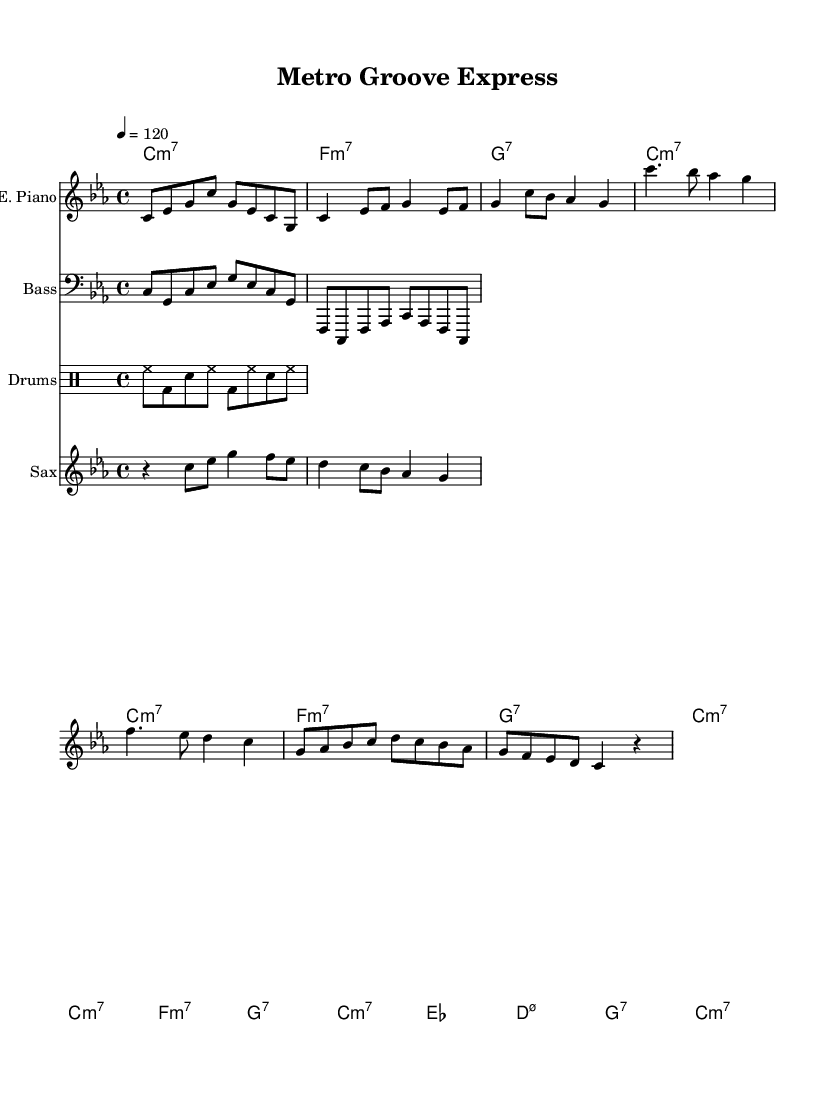What is the key signature of this music? The key signature indicated in the sheet music is C minor, which corresponds to the presence of three flats. This can be inferred from the initial marking in the global section of the code stating \key c \minor.
Answer: C minor What is the time signature of this music? The time signature is found in the global section of the score, specified as \time 4/4. This means there are four beats in each measure and a quarter note gets one beat.
Answer: 4/4 What is the tempo marking for this piece? The tempo of the piece is indicated in the global section as 4 = 120, meaning there are 120 quarter note beats per minute. This tells the performer the speed at which to play the music.
Answer: 120 What instrument plays the introductory melody? The introductory melody is performed by the electric piano, as indicated by the \new Staff with the label "E. Piano" preceding the electric piano music notation in the code.
Answer: Electric Piano How many measures are in the chorus section? To determine the number of measures in the chorus, we count the measures represented under the Chorus section of the electric piano part. There are four measures in this section.
Answer: 4 What chords are used in the bridge section? The bridge section consists of four chord names identified in the chordNames part of the code. They are es1, d:m7.5-, g:7, and c:m7, which indicate the harmonic structure for this part of the piece.
Answer: es1, d:m7.5-, g:7, c:m7 How does the jazz-funk influence manifest in this piece? The jazz-funk influence is evident through the syncopated rhythms in the drum pattern and bass line, as well as the improvisational feel provided by the saxophone, which is characteristic of jazz-funk fusion. The overall groove ties into the urban transit theme, enhancing the dynamic quality of the music.
Answer: Syncopated rhythms 